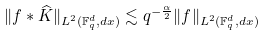<formula> <loc_0><loc_0><loc_500><loc_500>\| f \ast \widehat { K } \| _ { L ^ { 2 } ( { \mathbb { F } _ { q } ^ { d } } , d x ) } \lesssim q ^ { - \frac { \alpha } { 2 } } \| f \| _ { L ^ { 2 } ( { \mathbb { F } _ { q } ^ { d } } , d x ) }</formula> 